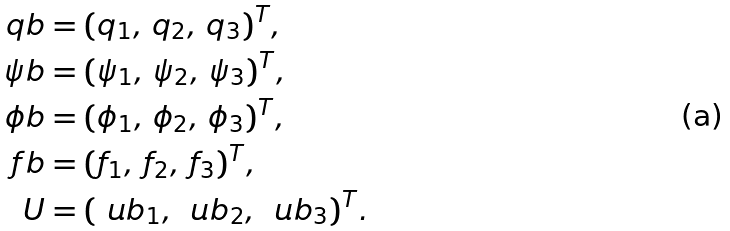<formula> <loc_0><loc_0><loc_500><loc_500>\ q b & = ( q _ { 1 } , \, q _ { 2 } , \, q _ { 3 } ) ^ { T } , \\ \psi b & = ( \psi _ { 1 } , \, \psi _ { 2 } , \, \psi _ { 3 } ) ^ { T } , \\ \phi b & = ( \phi _ { 1 } , \, \phi _ { 2 } , \, \phi _ { 3 } ) ^ { T } , \\ \ f b & = ( f _ { 1 } , \, f _ { 2 } , \, f _ { 3 } ) ^ { T } , \\ U & = ( \ u b _ { 1 } , \, \ u b _ { 2 } , \, \ u b _ { 3 } ) ^ { T } .</formula> 